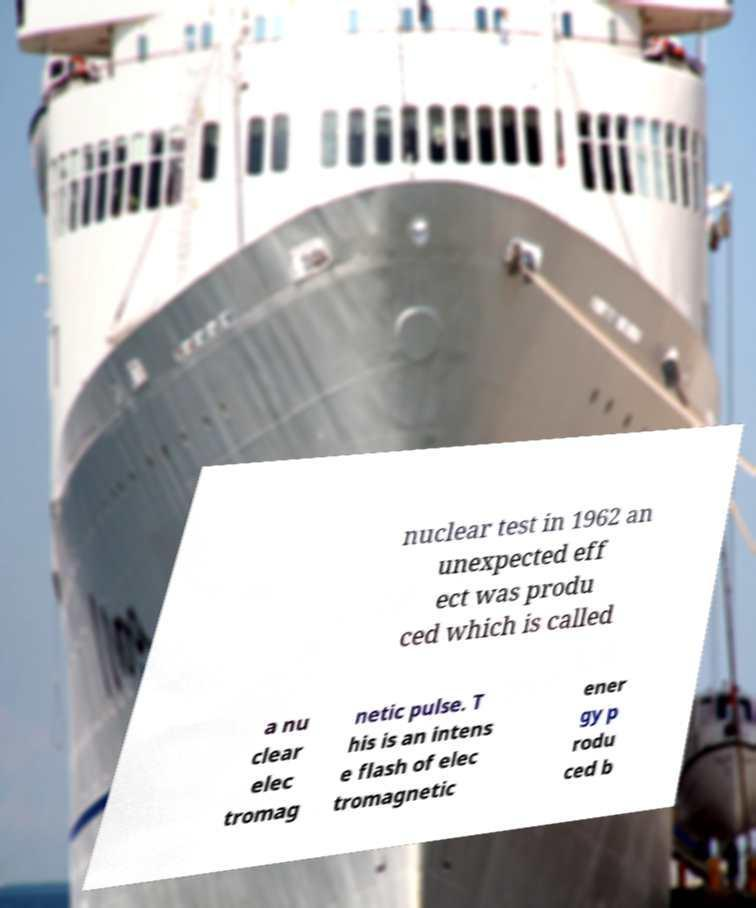Can you accurately transcribe the text from the provided image for me? nuclear test in 1962 an unexpected eff ect was produ ced which is called a nu clear elec tromag netic pulse. T his is an intens e flash of elec tromagnetic ener gy p rodu ced b 